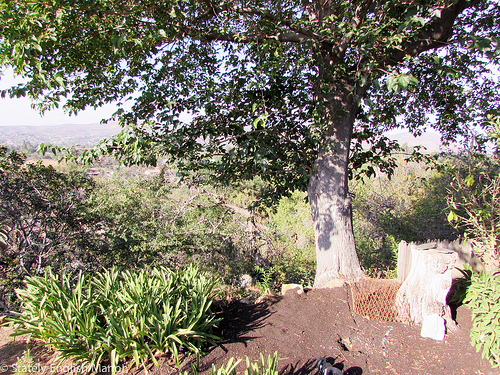<image>
Can you confirm if the plant is on the tree? No. The plant is not positioned on the tree. They may be near each other, but the plant is not supported by or resting on top of the tree. 